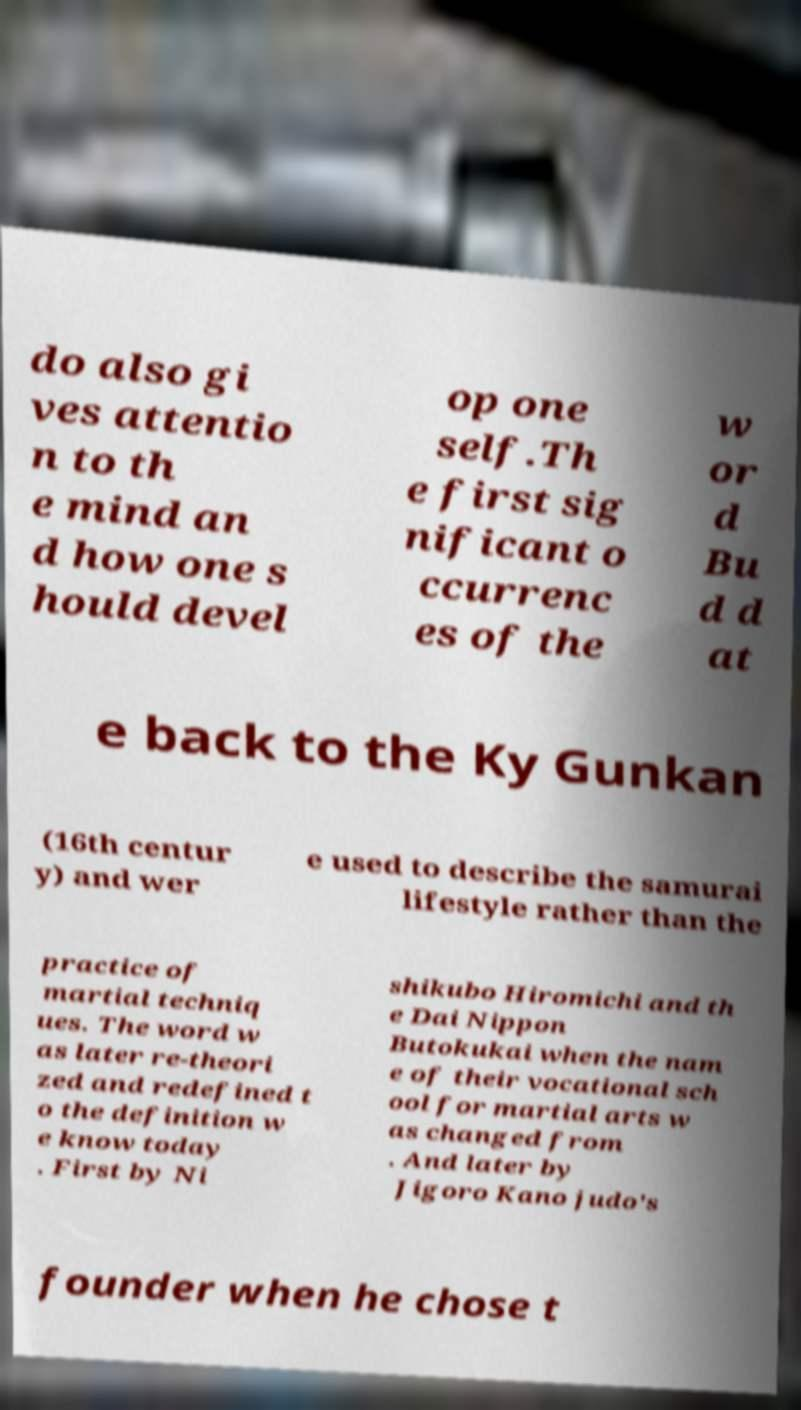Please read and relay the text visible in this image. What does it say? do also gi ves attentio n to th e mind an d how one s hould devel op one self.Th e first sig nificant o ccurrenc es of the w or d Bu d d at e back to the Ky Gunkan (16th centur y) and wer e used to describe the samurai lifestyle rather than the practice of martial techniq ues. The word w as later re-theori zed and redefined t o the definition w e know today . First by Ni shikubo Hiromichi and th e Dai Nippon Butokukai when the nam e of their vocational sch ool for martial arts w as changed from . And later by Jigoro Kano judo's founder when he chose t 